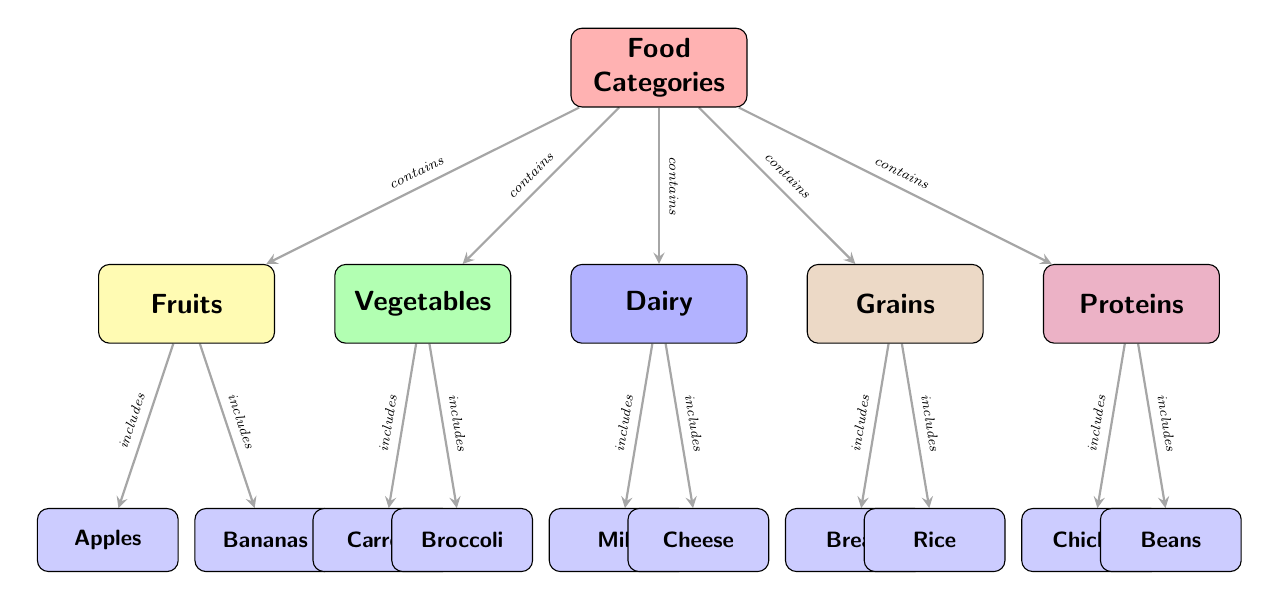What are the five main food categories shown in the diagram? The diagram lists five food categories, which are Fruits, Vegetables, Dairy, Grains, and Proteins, directly represented as nodes connected to the main node "Food Categories."
Answer: Fruits, Vegetables, Dairy, Grains, Proteins Which food item corresponds to the category "Dairy"? The diagram clearly shows two food items connected under the "Dairy" category: Milk and Cheese. Milk is the first listed item, followed by Cheese.
Answer: Milk, Cheese How many food categories are included in the diagram? The main node "Food Categories" branches out into five different food categories, counted directly from the diagram's layout.
Answer: 5 What type of relationship exists between "Fruits" and "Apples"? The diagram states that "Fruits" includes "Apples," indicating a parent-child relationship where "Fruits" is a broader category that encompasses "Apples."
Answer: includes Which food category encompasses the food item "Broccoli"? The diagram shows that "Broccoli" is included under the "Vegetables" food category, confirming the classification.
Answer: Vegetables Identify a food item that is classified under the "Proteins" category. The diagram lists two food items under "Proteins," specifically "Chicken" and "Beans," with "Chicken" being the first in the sequence.
Answer: Chicken If a student is looking for grain options, which food items can they select from? The diagram indicates that "Bread" and "Rice" are under the "Grains" category, providing the available options for grains.
Answer: Bread, Rice What node comes directly after "Food Categories" in terms of food types? "Food Categories" connects directly to the various food categories, and the first one listed is "Fruits."
Answer: Fruits 